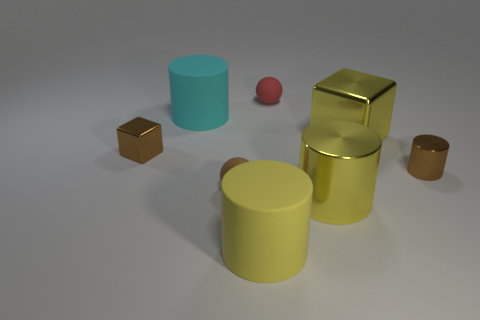What material is the tiny sphere that is the same color as the tiny block?
Provide a succinct answer. Rubber. Is the color of the large shiny cylinder the same as the big cube?
Offer a very short reply. Yes. There is a small brown object that is made of the same material as the large cyan object; what is its shape?
Your answer should be compact. Sphere. There is a cube that is behind the small brown block left of the tiny metallic cylinder in front of the cyan matte thing; what is it made of?
Your answer should be compact. Metal. What number of objects are either big yellow things on the right side of the small red rubber object or tiny red objects?
Your answer should be compact. 3. What number of other objects are the same shape as the tiny red thing?
Offer a terse response. 1. Is the number of tiny spheres that are behind the brown block greater than the number of big purple metallic balls?
Provide a short and direct response. Yes. There is another rubber object that is the same shape as the tiny red thing; what is its size?
Offer a very short reply. Small. What is the shape of the small brown rubber object?
Your answer should be compact. Sphere. What shape is the red rubber object that is the same size as the brown rubber thing?
Make the answer very short. Sphere. 